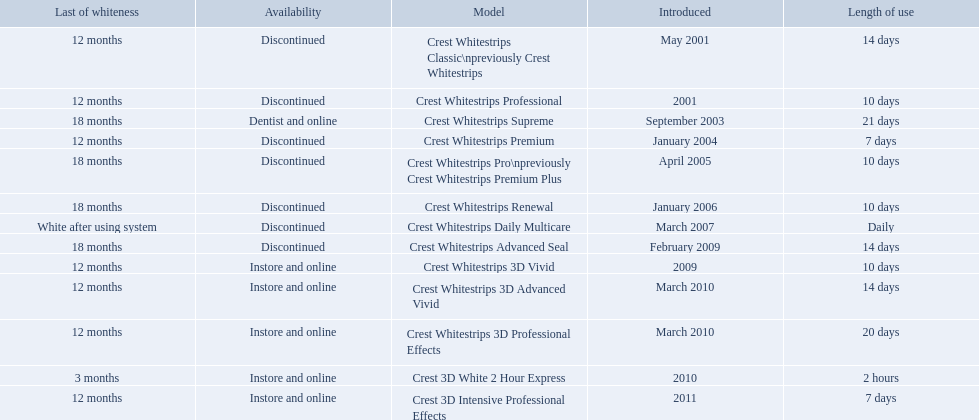What are all the models? Crest Whitestrips Classic\npreviously Crest Whitestrips, Crest Whitestrips Professional, Crest Whitestrips Supreme, Crest Whitestrips Premium, Crest Whitestrips Pro\npreviously Crest Whitestrips Premium Plus, Crest Whitestrips Renewal, Crest Whitestrips Daily Multicare, Crest Whitestrips Advanced Seal, Crest Whitestrips 3D Vivid, Crest Whitestrips 3D Advanced Vivid, Crest Whitestrips 3D Professional Effects, Crest 3D White 2 Hour Express, Crest 3D Intensive Professional Effects. Of these, for which can a ratio be calculated for 'length of use' to 'last of whiteness'? Crest Whitestrips Classic\npreviously Crest Whitestrips, Crest Whitestrips Professional, Crest Whitestrips Supreme, Crest Whitestrips Premium, Crest Whitestrips Pro\npreviously Crest Whitestrips Premium Plus, Crest Whitestrips Renewal, Crest Whitestrips Advanced Seal, Crest Whitestrips 3D Vivid, Crest Whitestrips 3D Advanced Vivid, Crest Whitestrips 3D Professional Effects, Crest 3D White 2 Hour Express, Crest 3D Intensive Professional Effects. Which has the highest ratio? Crest Whitestrips Supreme. What were the models of crest whitestrips? Crest Whitestrips Classic\npreviously Crest Whitestrips, Crest Whitestrips Professional, Crest Whitestrips Supreme, Crest Whitestrips Premium, Crest Whitestrips Pro\npreviously Crest Whitestrips Premium Plus, Crest Whitestrips Renewal, Crest Whitestrips Daily Multicare, Crest Whitestrips Advanced Seal, Crest Whitestrips 3D Vivid, Crest Whitestrips 3D Advanced Vivid, Crest Whitestrips 3D Professional Effects, Crest 3D White 2 Hour Express, Crest 3D Intensive Professional Effects. When were they introduced? May 2001, 2001, September 2003, January 2004, April 2005, January 2006, March 2007, February 2009, 2009, March 2010, March 2010, 2010, 2011. And what is their availability? Discontinued, Discontinued, Dentist and online, Discontinued, Discontinued, Discontinued, Discontinued, Discontinued, Instore and online, Instore and online, Instore and online, Instore and online, Instore and online. Along crest whitestrips 3d vivid, which discontinued model was released in 2009? Crest Whitestrips Advanced Seal. 